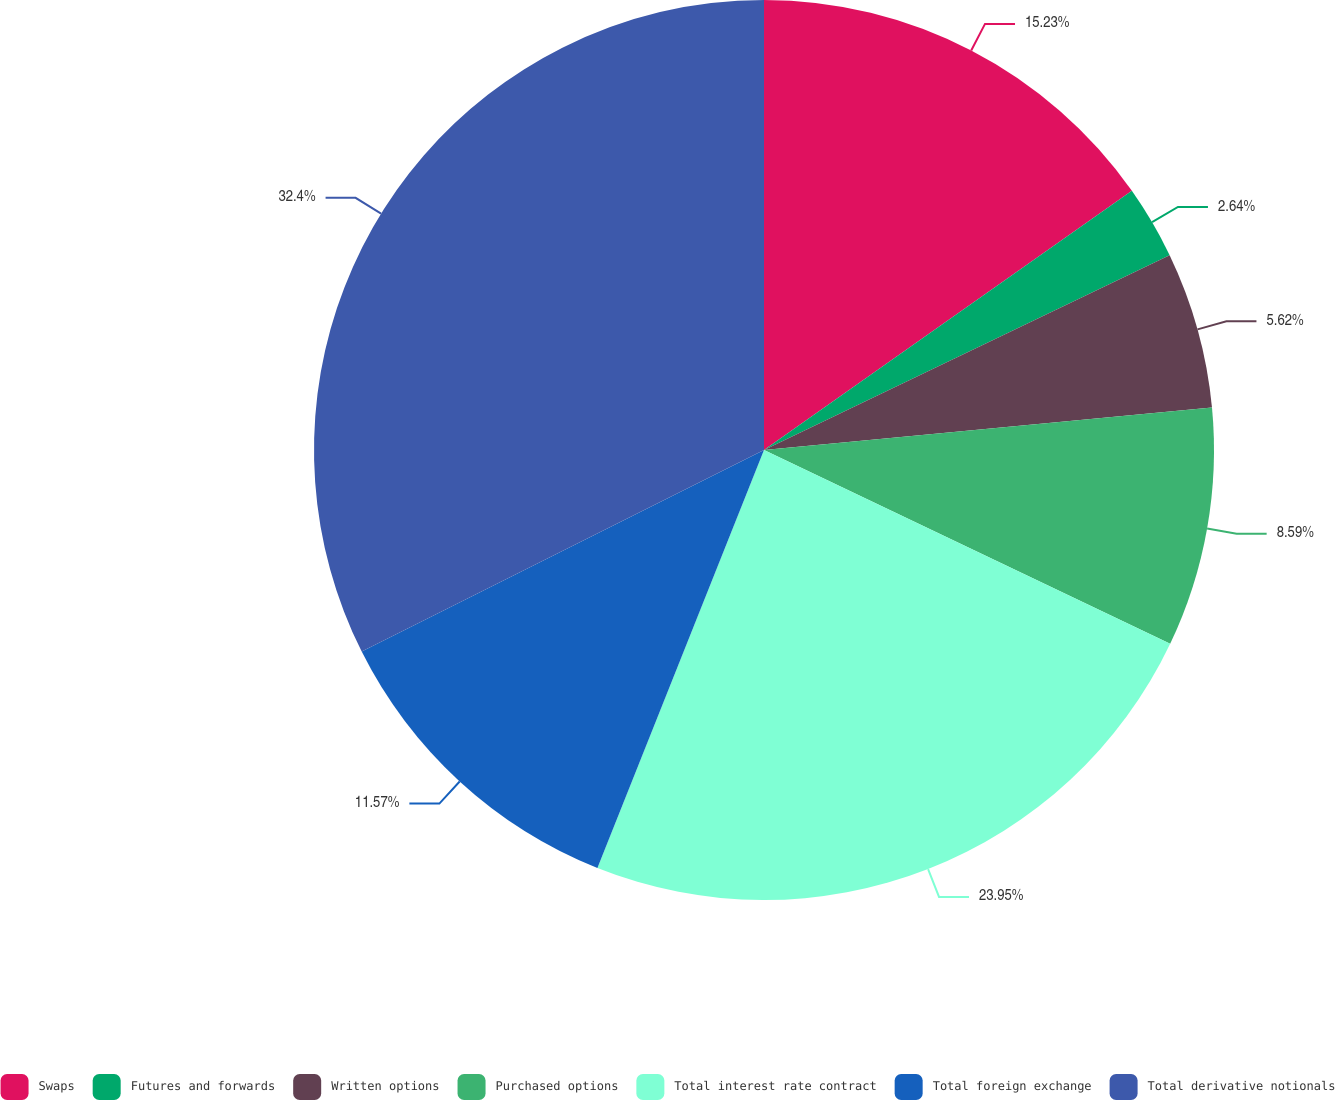Convert chart. <chart><loc_0><loc_0><loc_500><loc_500><pie_chart><fcel>Swaps<fcel>Futures and forwards<fcel>Written options<fcel>Purchased options<fcel>Total interest rate contract<fcel>Total foreign exchange<fcel>Total derivative notionals<nl><fcel>15.23%<fcel>2.64%<fcel>5.62%<fcel>8.59%<fcel>23.95%<fcel>11.57%<fcel>32.39%<nl></chart> 